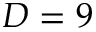Convert formula to latex. <formula><loc_0><loc_0><loc_500><loc_500>D = 9</formula> 